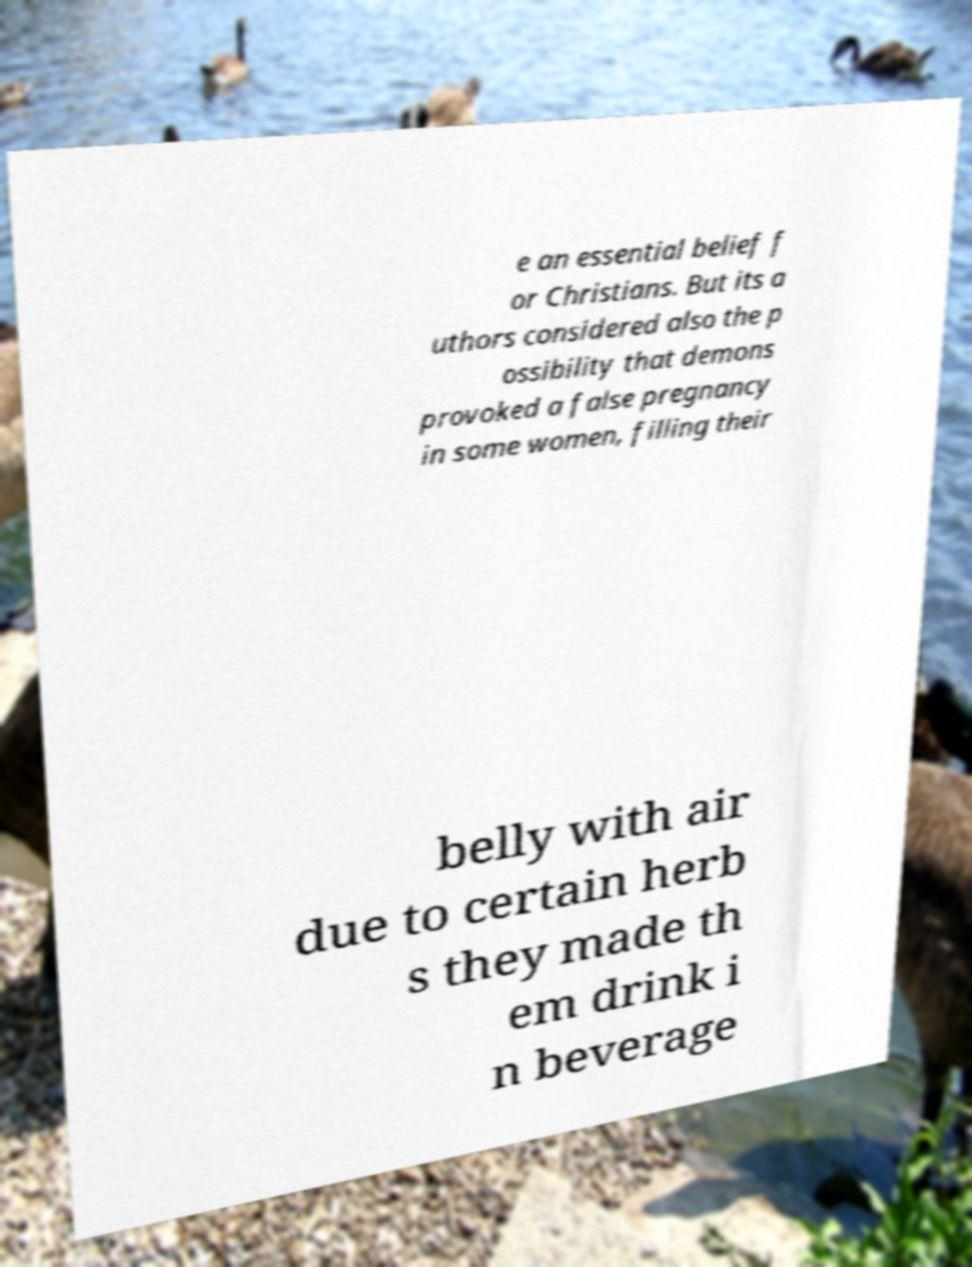I need the written content from this picture converted into text. Can you do that? e an essential belief f or Christians. But its a uthors considered also the p ossibility that demons provoked a false pregnancy in some women, filling their belly with air due to certain herb s they made th em drink i n beverage 